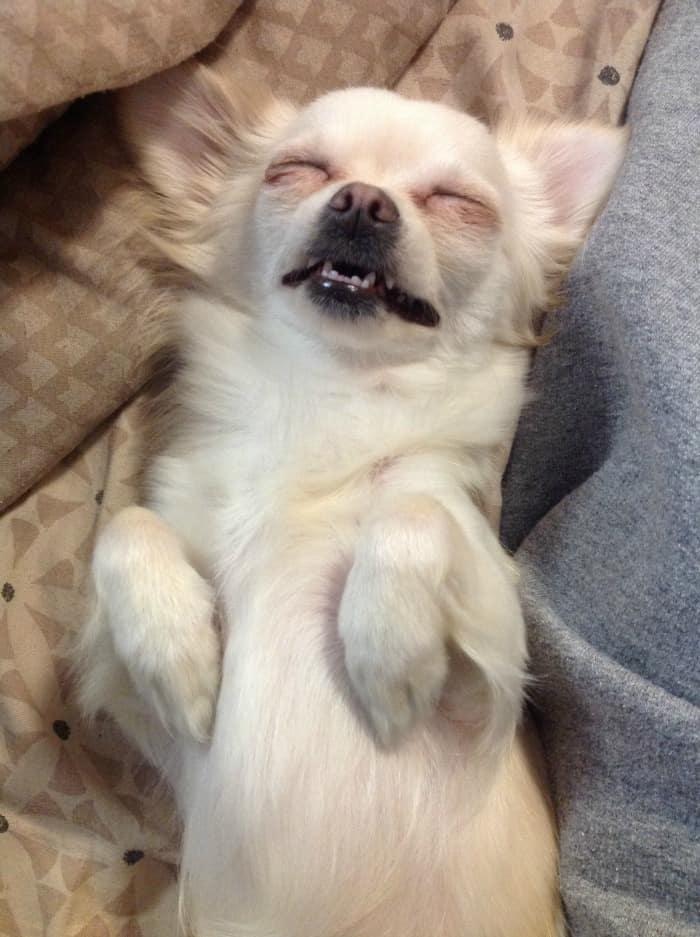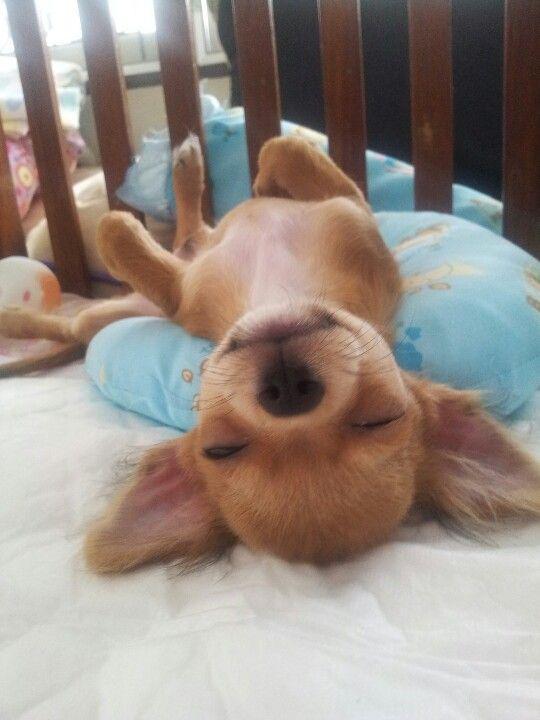The first image is the image on the left, the second image is the image on the right. Given the left and right images, does the statement "A puppy with dark and light fur is sleeping with a dimensional object between its paws." hold true? Answer yes or no. No. The first image is the image on the left, the second image is the image on the right. Evaluate the accuracy of this statement regarding the images: "In the left image, a dog is cuddling another object.". Is it true? Answer yes or no. No. 